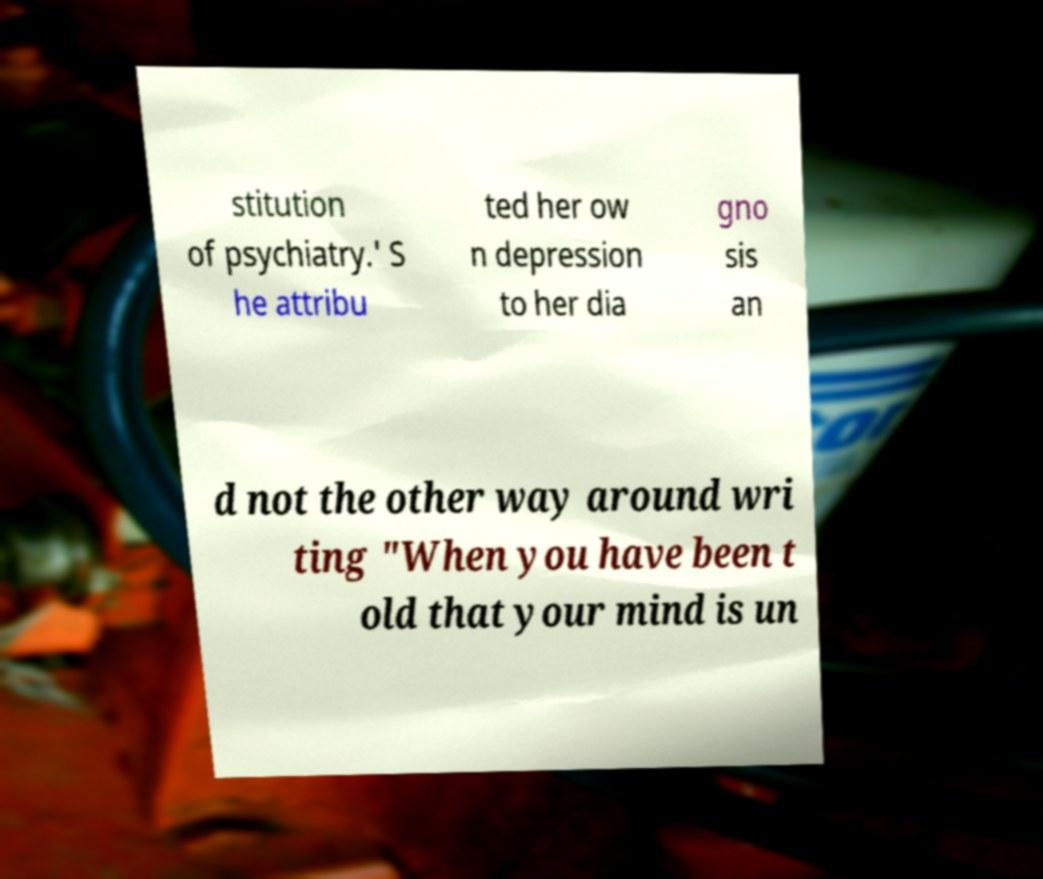Please read and relay the text visible in this image. What does it say? stitution of psychiatry.' S he attribu ted her ow n depression to her dia gno sis an d not the other way around wri ting "When you have been t old that your mind is un 